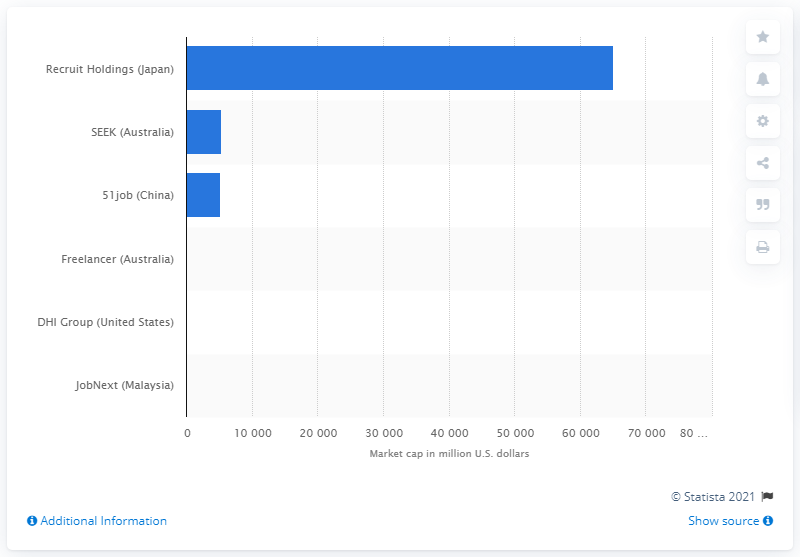Outline some significant characteristics in this image. The market capitalization of Recruit Holdings is approximately 650,370. SEEK's market capitalization is currently 5369. 